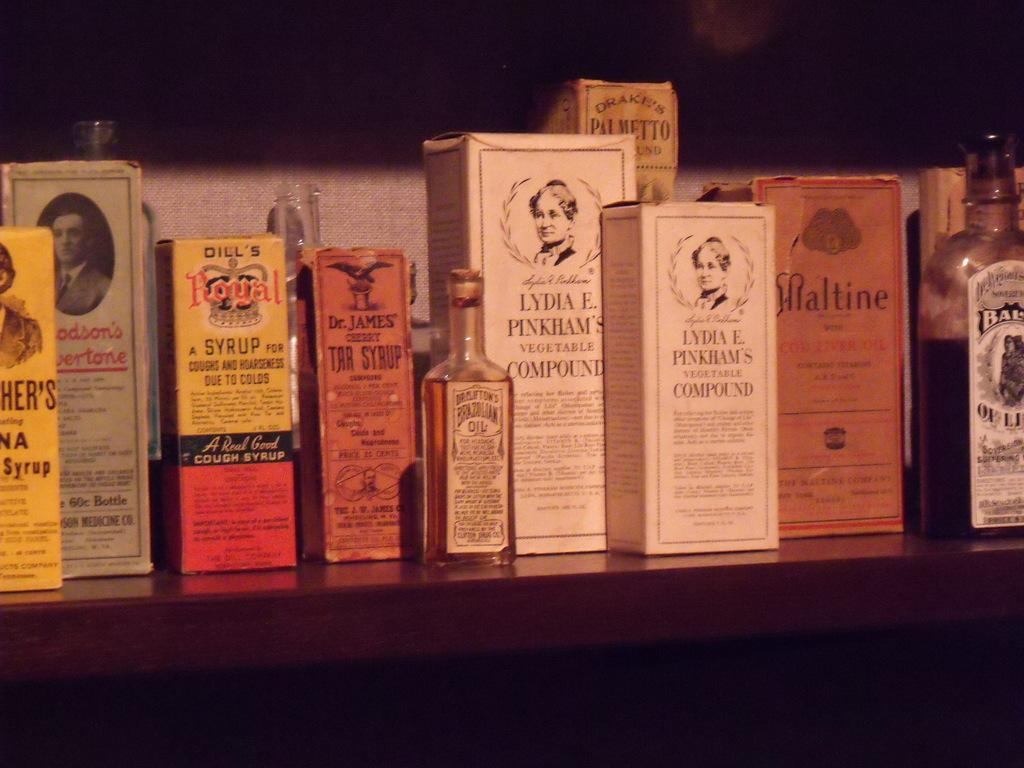<image>
Summarize the visual content of the image. Vintage medicinal supplies such as Dill's Royal Syrup are displayed on a shelf. 